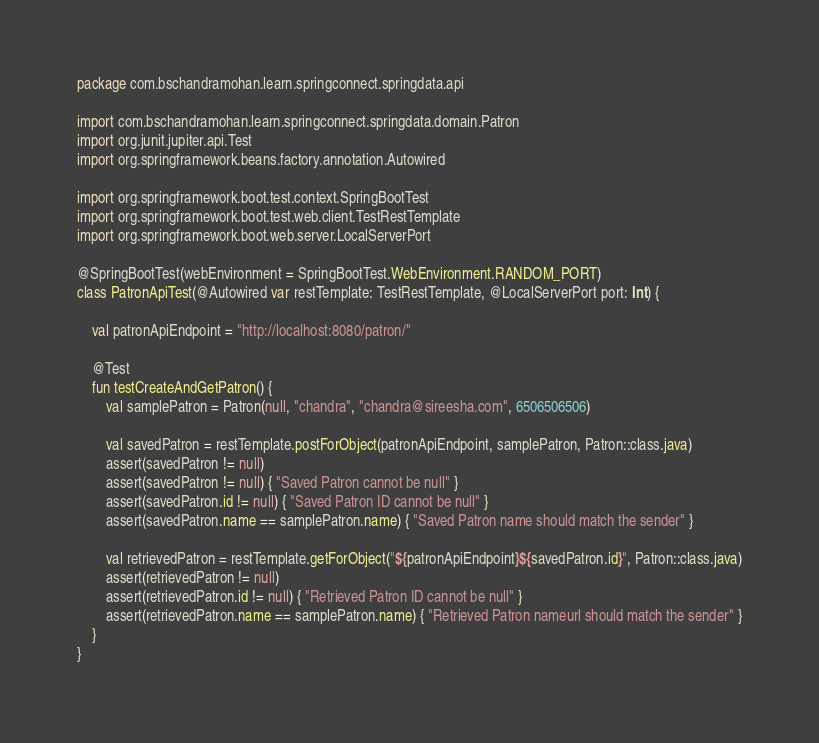Convert code to text. <code><loc_0><loc_0><loc_500><loc_500><_Kotlin_>package com.bschandramohan.learn.springconnect.springdata.api

import com.bschandramohan.learn.springconnect.springdata.domain.Patron
import org.junit.jupiter.api.Test
import org.springframework.beans.factory.annotation.Autowired

import org.springframework.boot.test.context.SpringBootTest
import org.springframework.boot.test.web.client.TestRestTemplate
import org.springframework.boot.web.server.LocalServerPort

@SpringBootTest(webEnvironment = SpringBootTest.WebEnvironment.RANDOM_PORT)
class PatronApiTest(@Autowired var restTemplate: TestRestTemplate, @LocalServerPort port: Int) {

    val patronApiEndpoint = "http://localhost:8080/patron/"

    @Test
    fun testCreateAndGetPatron() {
        val samplePatron = Patron(null, "chandra", "chandra@sireesha.com", 6506506506)

        val savedPatron = restTemplate.postForObject(patronApiEndpoint, samplePatron, Patron::class.java)
        assert(savedPatron != null)
        assert(savedPatron != null) { "Saved Patron cannot be null" }
        assert(savedPatron.id != null) { "Saved Patron ID cannot be null" }
        assert(savedPatron.name == samplePatron.name) { "Saved Patron name should match the sender" }

        val retrievedPatron = restTemplate.getForObject("${patronApiEndpoint}${savedPatron.id}", Patron::class.java)
        assert(retrievedPatron != null)
        assert(retrievedPatron.id != null) { "Retrieved Patron ID cannot be null" }
        assert(retrievedPatron.name == samplePatron.name) { "Retrieved Patron nameurl should match the sender" }
    }
}
</code> 